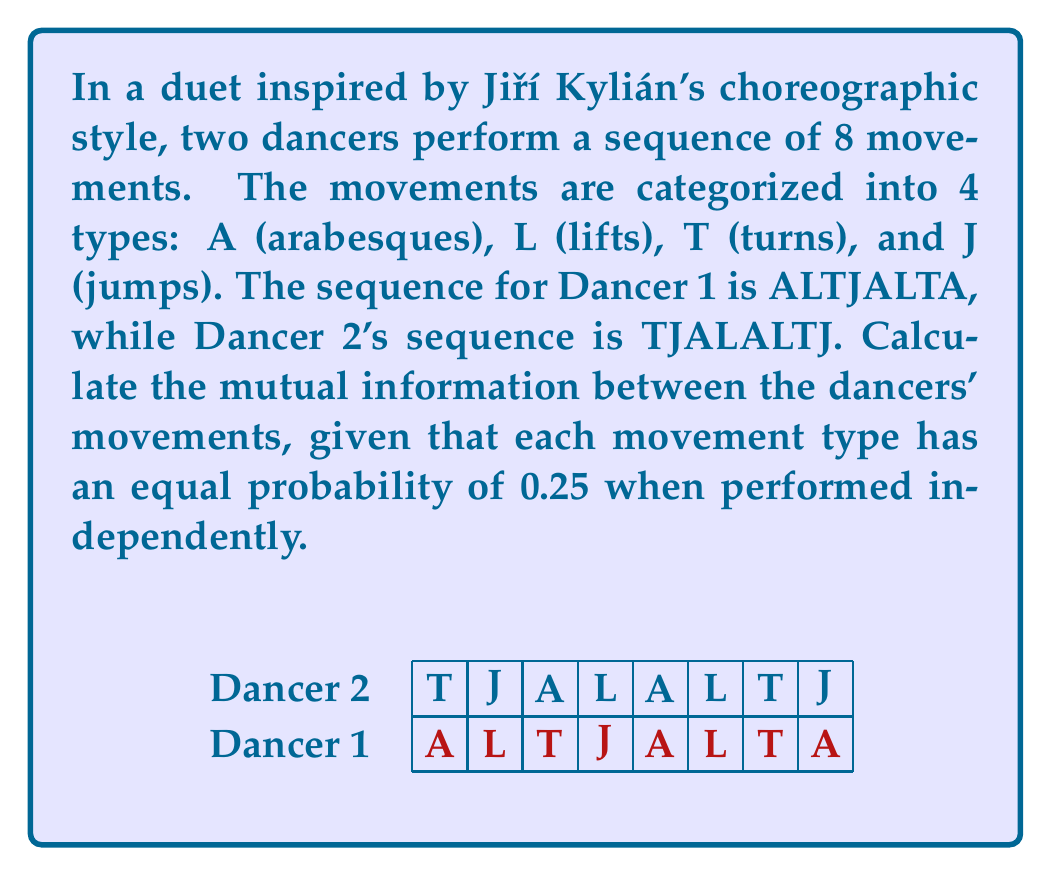Help me with this question. To calculate the mutual information between the dancers' movements, we'll follow these steps:

1) First, we need to calculate the joint probability distribution $p(x,y)$ for the movements of both dancers. We have 8 pairs of movements:

   (A,T), (L,J), (T,A), (J,L), (A,A), (L,L), (T,T), (A,J)

2) Count the occurrences of each pair:
   (A,T): 1, (L,J): 1, (T,A): 1, (J,L): 1, (A,A): 1, (L,L): 1, (T,T): 1, (A,J): 1

3) Calculate $p(x,y)$ for each pair:
   $p(x,y) = \frac{\text{occurrences}}{8} = \frac{1}{8} = 0.125$ for all pairs

4) Calculate marginal probabilities $p(x)$ and $p(y)$:
   For Dancer 1: $p(A) = \frac{3}{8}, p(L) = \frac{2}{8}, p(T) = \frac{2}{8}, p(J) = \frac{1}{8}$
   For Dancer 2: $p(A) = \frac{2}{8}, p(L) = \frac{2}{8}, p(T) = \frac{2}{8}, p(J) = \frac{2}{8}$

5) The mutual information is given by:
   $$I(X;Y) = \sum_{x,y} p(x,y) \log_2 \frac{p(x,y)}{p(x)p(y)}$$

6) Calculate for each pair:
   $(A,T): 0.125 \log_2 \frac{0.125}{(3/8)(2/8)} = 0.125 \log_2 \frac{4}{3} = 0.0359$
   $(L,J): 0.125 \log_2 \frac{0.125}{(2/8)(2/8)} = 0.125 \log_2 2 = 0.125$
   $(T,A): 0.125 \log_2 \frac{0.125}{(2/8)(2/8)} = 0.125 \log_2 2 = 0.125$
   $(J,L): 0.125 \log_2 \frac{0.125}{(1/8)(2/8)} = 0.125 \log_2 4 = 0.25$
   $(A,A): 0.125 \log_2 \frac{0.125}{(3/8)(2/8)} = 0.125 \log_2 \frac{4}{3} = 0.0359$
   $(L,L): 0.125 \log_2 \frac{0.125}{(2/8)(2/8)} = 0.125 \log_2 2 = 0.125$
   $(T,T): 0.125 \log_2 \frac{0.125}{(2/8)(2/8)} = 0.125 \log_2 2 = 0.125$
   $(A,J): 0.125 \log_2 \frac{0.125}{(3/8)(2/8)} = 0.125 \log_2 \frac{4}{3} = 0.0359$

7) Sum all values:
   $I(X;Y) = 0.0359 + 0.125 + 0.125 + 0.25 + 0.0359 + 0.125 + 0.125 + 0.0359 = 0.8577$ bits

Thus, the mutual information between the dancers' movements is approximately 0.8577 bits.
Answer: 0.8577 bits 